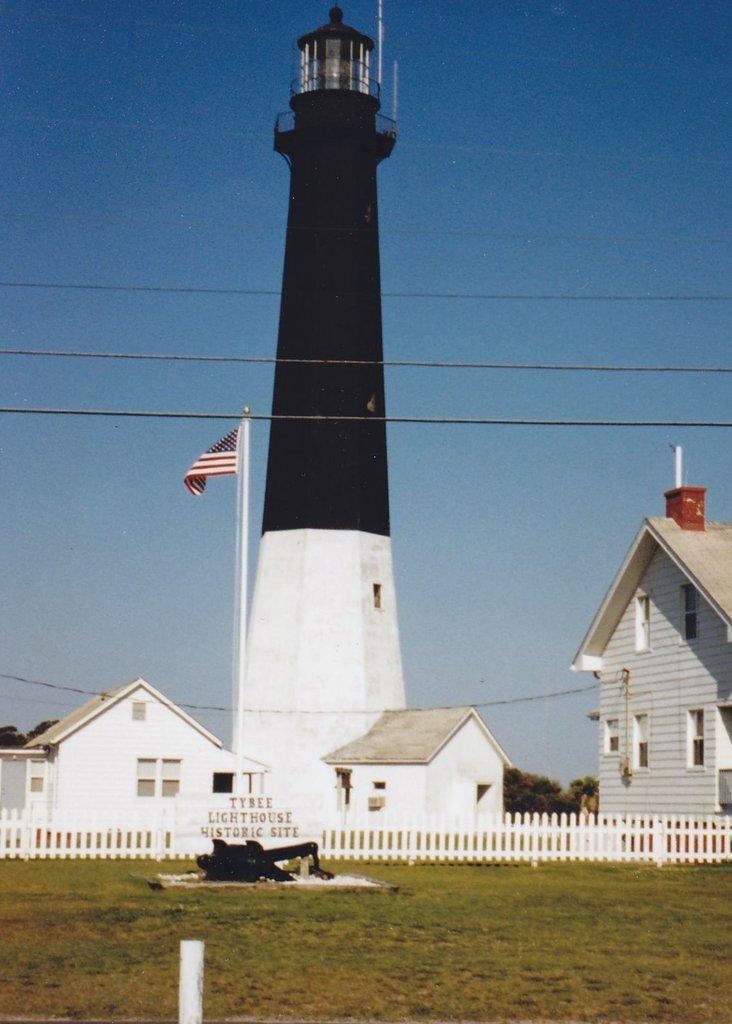What is located in the foreground of the image? In the foreground of the image, there is a pole, grass land, an object, a flag, cables, buildings, a railing, and a lighthouse. Can you describe the object in the foreground? Unfortunately, the specific object in the foreground cannot be identified from the provided facts. What is attached to the pole in the foreground? The flag is attached to the pole in the foreground. What can be seen in the background of the image? In the background of the image, there are trees and sky visible. Is the area in the image known for its quiet atmosphere? The provided facts do not mention anything about the atmosphere or noise level in the image. Can you describe the magic that is present in the image? There is no mention of magic in the image or its contents. 